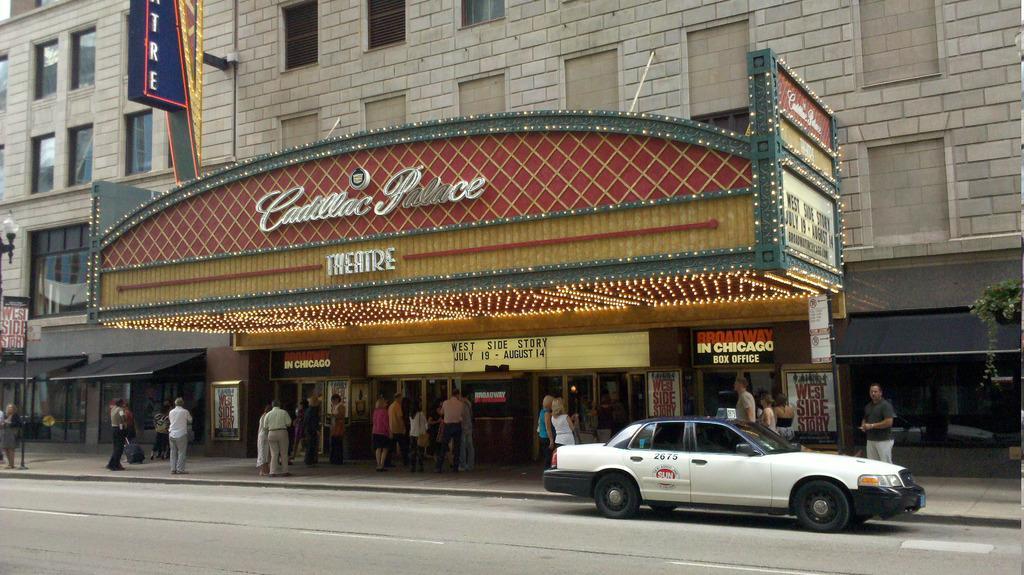Can you describe this image briefly? In this picture, we can see a few people, road, vehicle, stores, boards with text, poles, lights, and plants. 